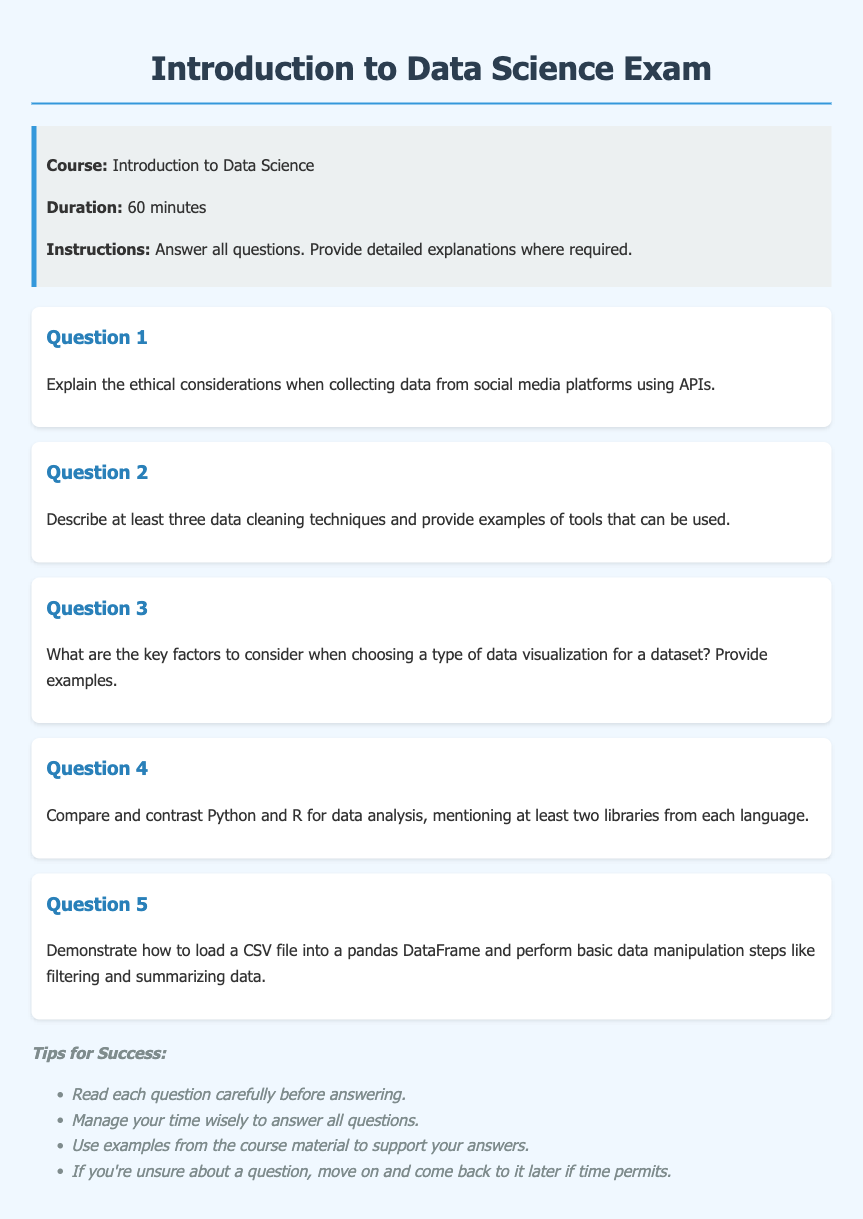What is the title of the document? The title is found in the header section of the document, specifying the main focus of the content.
Answer: Introduction to Data Science Exam What is the duration of the exam? The duration is explicitly mentioned in the exam information section, detailing how long students have to complete it.
Answer: 60 minutes What should students do with the questions? The instructions provide guidance on what is expected from the students during the exam.
Answer: Answer all questions Name one ethical consideration mentioned in the first question. The first question addresses the ethical aspects related to data collection from social media.
Answer: Ethical considerations List one tool used for data cleaning mentioned in the second question. The second question asks for examples of tools that are commonly used for data cleaning processes.
Answer: Examples of tools What is the focus of Question 3? The key factors that the question requires consideration of are related to visual representation of data.
Answer: Data visualization How many libraries should be mentioned when comparing Python and R in Question 4? The fourth question specifies a requirement for the number of libraries to discuss for each programming language.
Answer: Two libraries What is the final section of the document intended to provide? This section offers guidance and strategies to help students perform well on the exam.
Answer: Tips for Success 